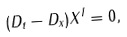<formula> <loc_0><loc_0><loc_500><loc_500>( D _ { t } - D _ { x } ) X ^ { I } = 0 ,</formula> 